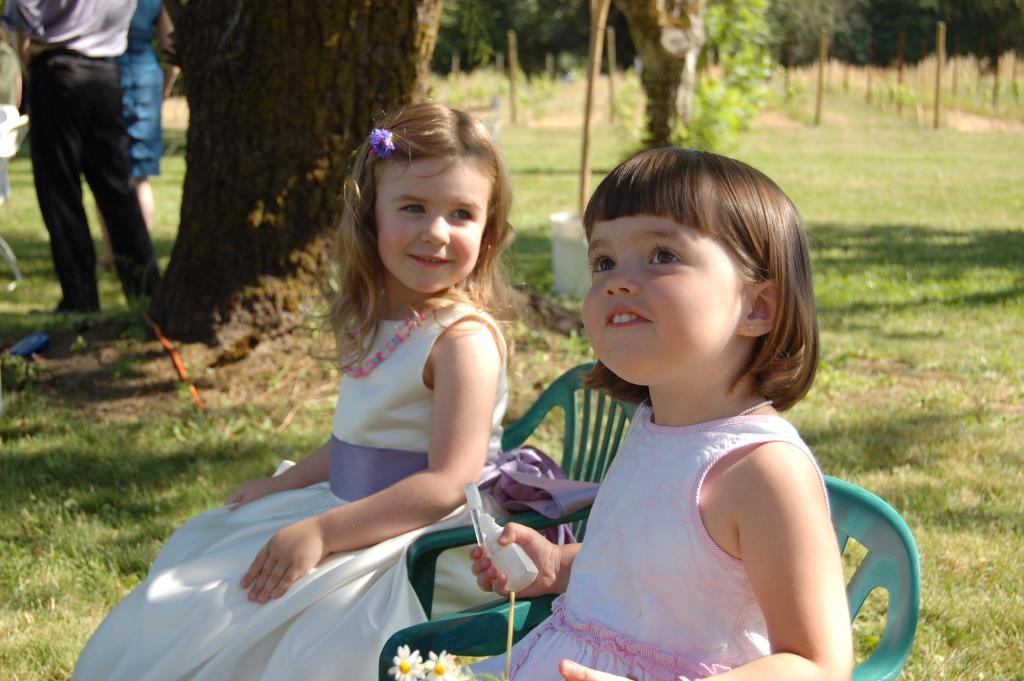How many girls are sitting in the image? There are two girls sitting on chairs in the image. What are the other people in the image doing? There are two persons standing on the left side in the image. What can be seen in the background of the image? There are trees in the background of the image. Is there a lake visible in the image? No, there is no lake present in the image. How many men are standing on the left side of the image? The provided facts do not specify the gender of the two persons standing on the left side, so we cannot determine if they are men or not. 